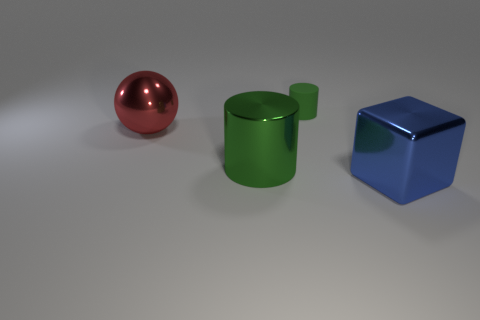Add 3 big yellow balls. How many objects exist? 7 Subtract all spheres. How many objects are left? 3 Add 2 large gray metal cubes. How many large gray metal cubes exist? 2 Subtract 0 blue balls. How many objects are left? 4 Subtract all red cylinders. Subtract all purple spheres. How many cylinders are left? 2 Subtract all green shiny cylinders. Subtract all brown matte blocks. How many objects are left? 3 Add 4 shiny objects. How many shiny objects are left? 7 